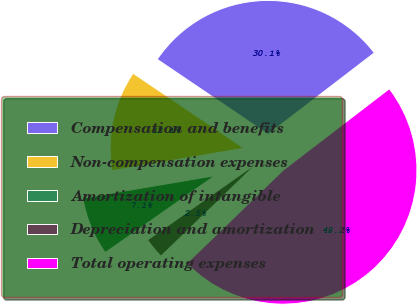Convert chart to OTSL. <chart><loc_0><loc_0><loc_500><loc_500><pie_chart><fcel>Compensation and benefits<fcel>Non-compensation expenses<fcel>Amortization of intangible<fcel>Depreciation and amortization<fcel>Total operating expenses<nl><fcel>30.13%<fcel>12.14%<fcel>7.06%<fcel>2.5%<fcel>48.18%<nl></chart> 